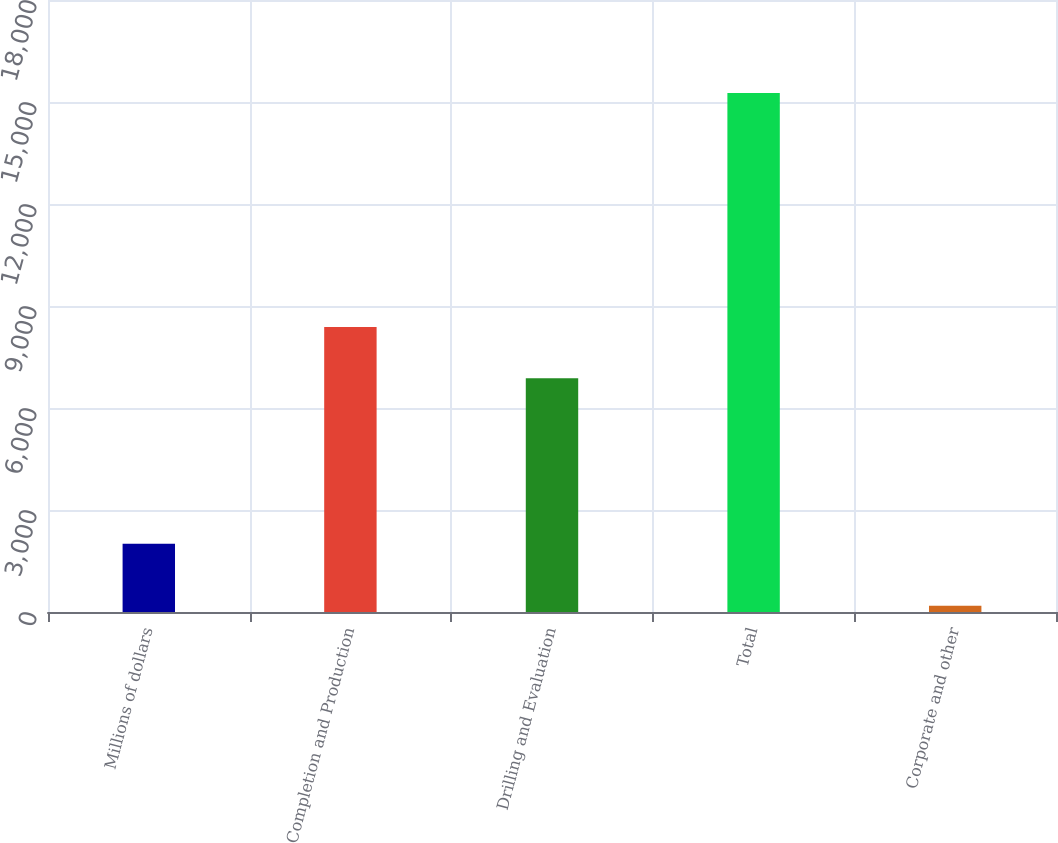Convert chart to OTSL. <chart><loc_0><loc_0><loc_500><loc_500><bar_chart><fcel>Millions of dollars<fcel>Completion and Production<fcel>Drilling and Evaluation<fcel>Total<fcel>Corporate and other<nl><fcel>2007<fcel>8386<fcel>6878<fcel>15264<fcel>186<nl></chart> 